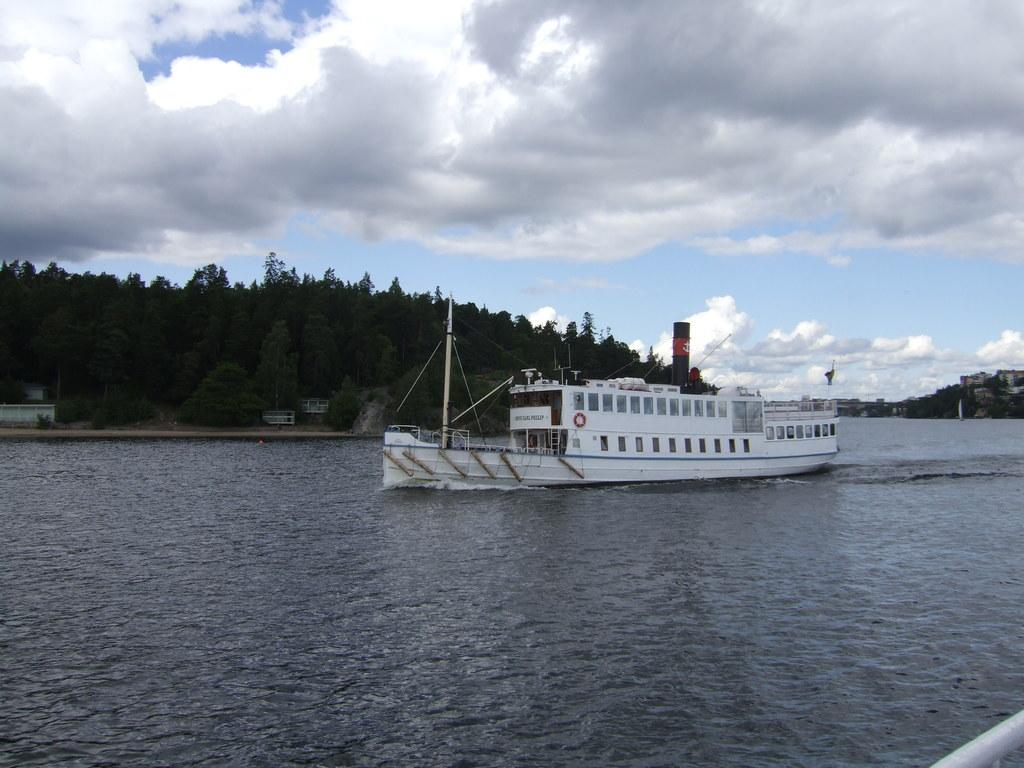What body of water is present at the bottom of the image? There is a river at the bottom of the image. What is in the river? There is a boat in the river. What can be seen in the background of the image? There are trees and the sky visible in the background of the image. How many spiders are crawling on the boat in the image? There are no spiders present in the image; it features a boat in a river with trees and the sky in the background. 